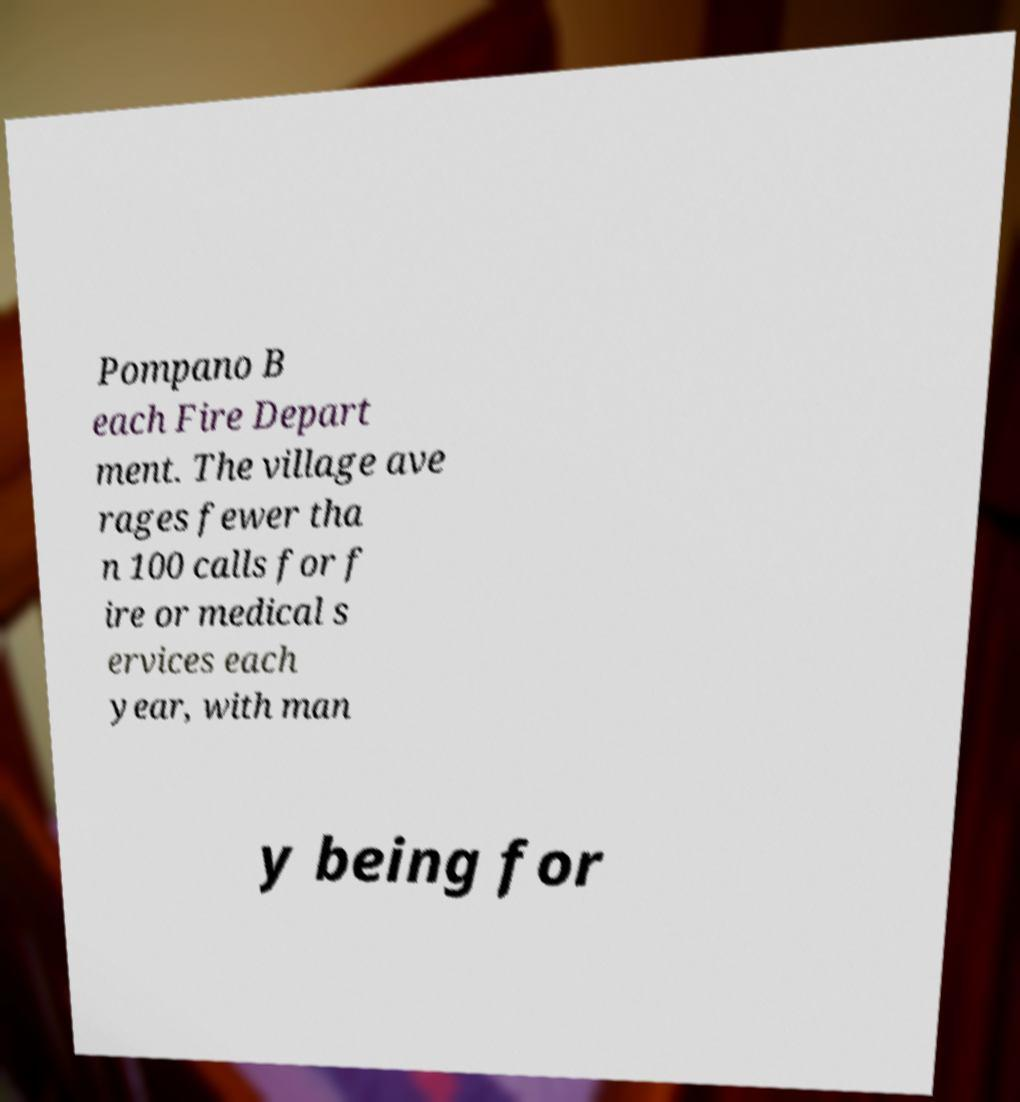Can you read and provide the text displayed in the image?This photo seems to have some interesting text. Can you extract and type it out for me? Pompano B each Fire Depart ment. The village ave rages fewer tha n 100 calls for f ire or medical s ervices each year, with man y being for 